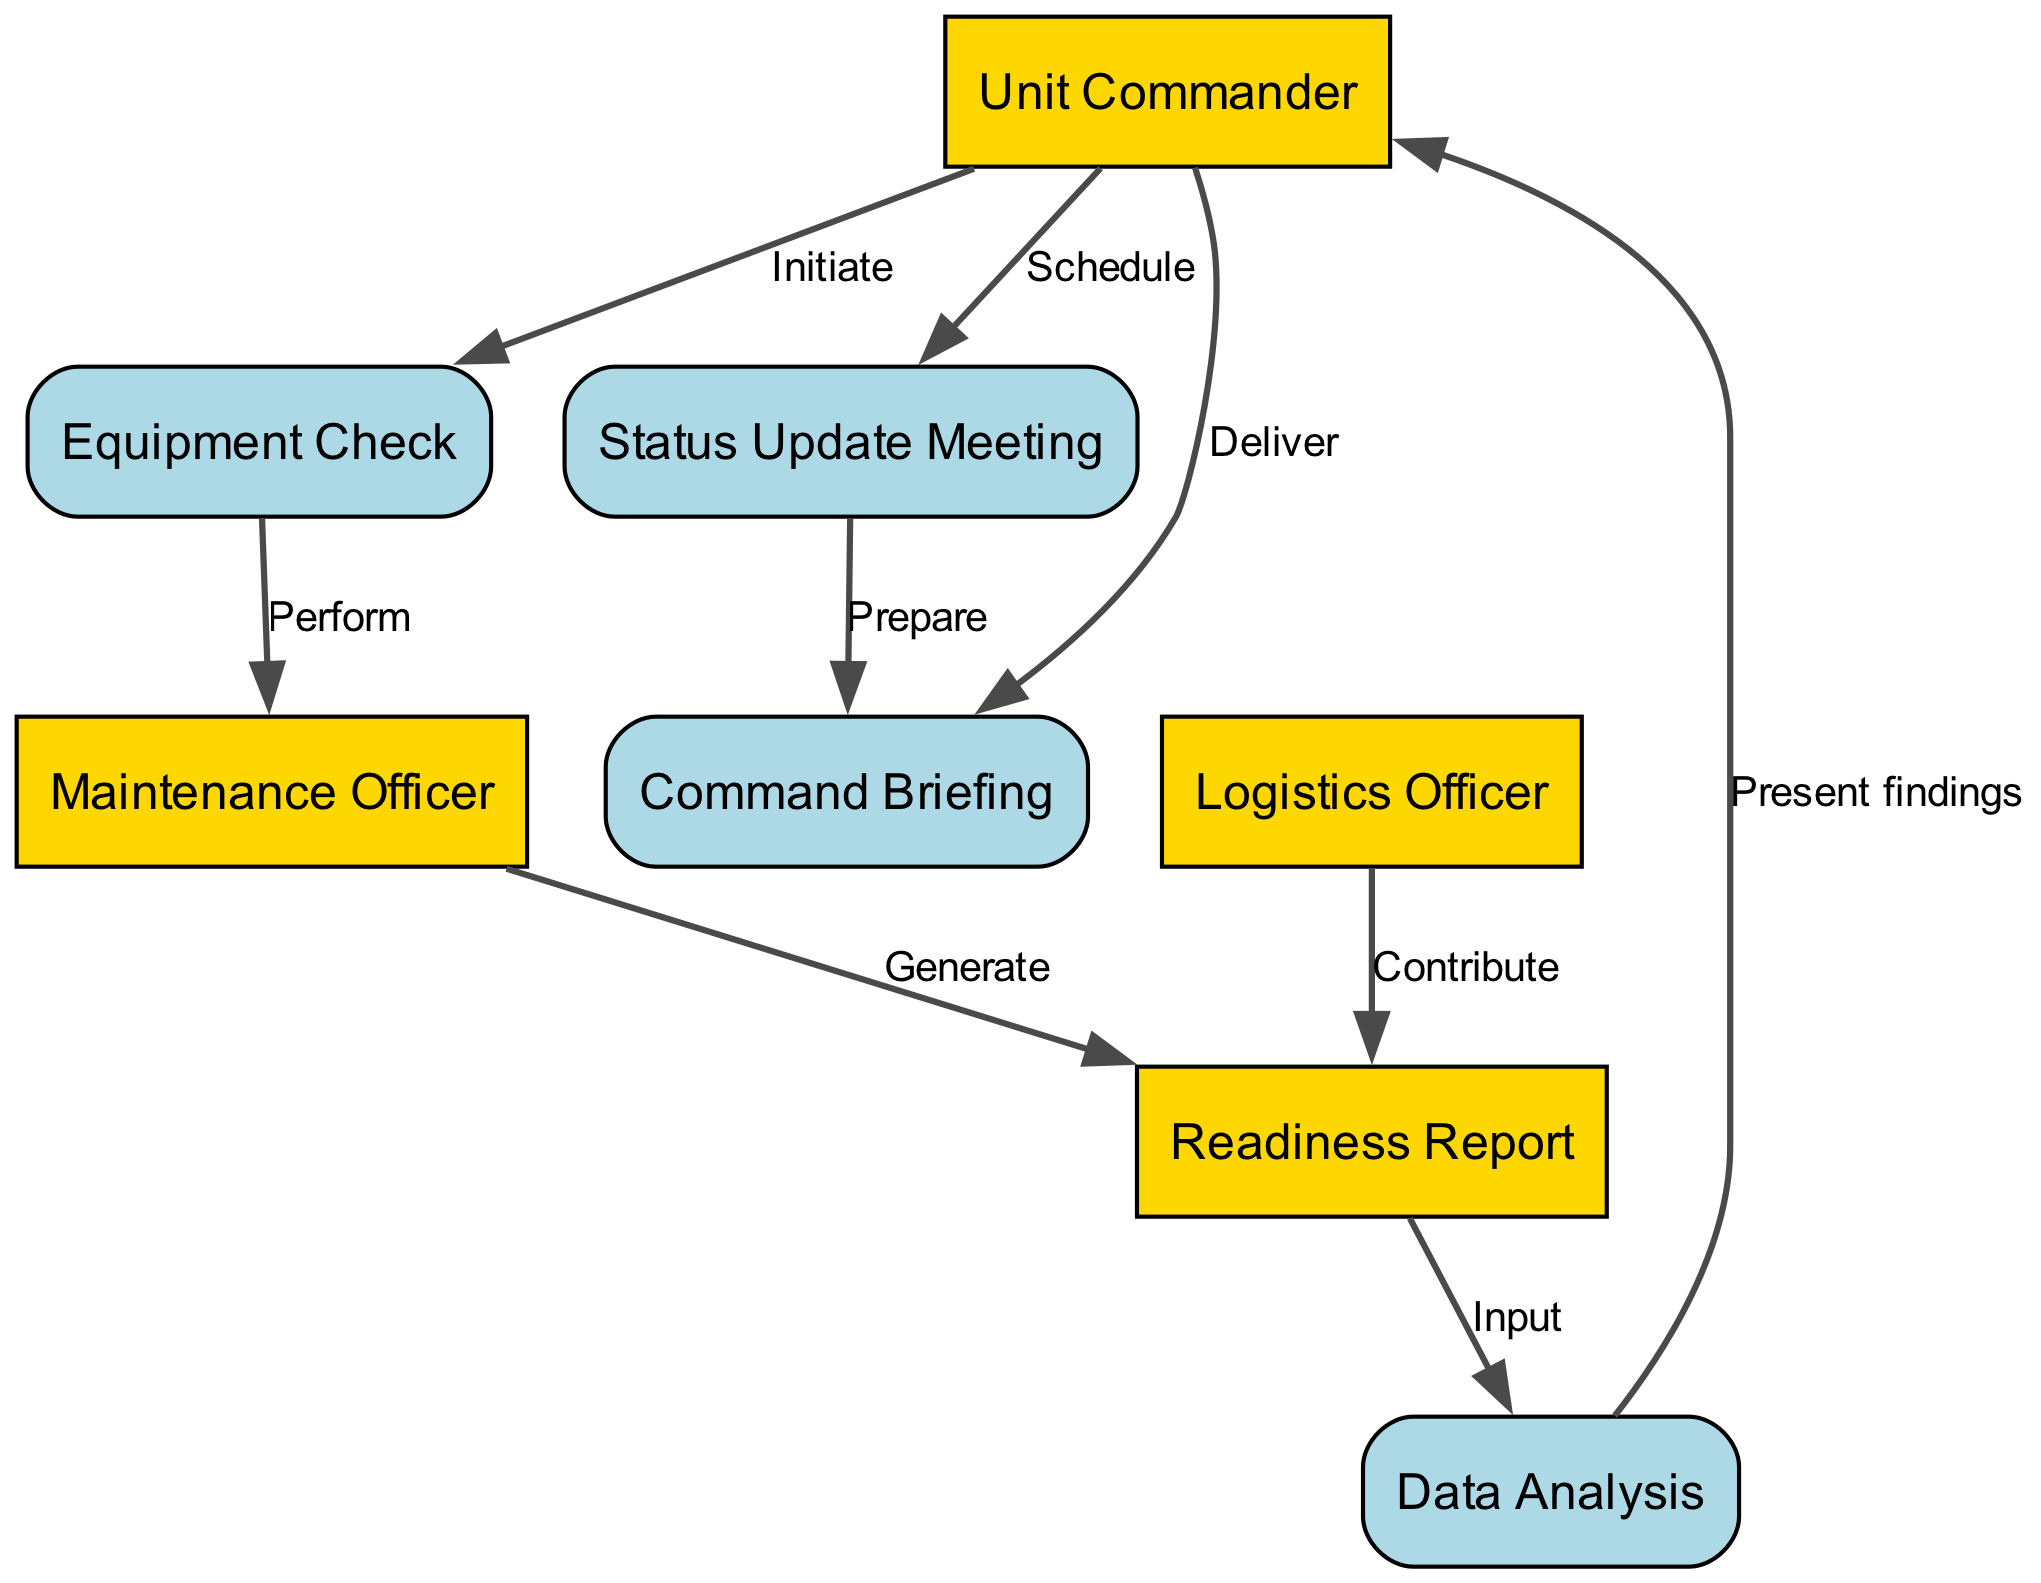What is the first process initiated in the diagram? The diagram shows that the first action is initiated by the Unit Commander who begins the Equipment Check. Therefore, the first process is Equipment Check.
Answer: Equipment Check How many actors are involved in the sequence diagram? There are four actors depicted in the diagram: Unit Commander, Maintenance Officer, Logistics Officer, and the object of the Readiness Report does not count as an actor. Thus, the total number of actors is four.
Answer: Four What does the Maintenance Officer generate as part of the sequence? According to the sequence, after performing the Equipment Check, the Maintenance Officer generates the Readiness Report as the next step.
Answer: Readiness Report Who is responsible for scheduling the Status Update Meeting? The diagram indicates that the Unit Commander is responsible for scheduling the Status Update Meeting after receiving the analyzed data.
Answer: Unit Commander What is the relationship between Data Analysis and Unit Commander? The Data Analysis process presents findings to the Unit Commander, establishing a direct informational flow between these two elements. This reflects a responsibility for the Unit Commander to consider these findings.
Answer: Present findings How many events are there in the sequence of this diagram? By reviewing the interactions illustrated in the diagram, there are a total of three distinct events: Status Update Meeting, Command Briefing, and the initial Equipment Check. Thus, the number of events is three.
Answer: Three What is the final action taken by the Unit Commander in the sequence? The last action taken by the Unit Commander is to deliver the Command Briefing, which concludes the processes involved in the sequence. Thus, the final action is to deliver the Command Briefing.
Answer: Deliver What does the Logistics Officer contribute to the Readiness Report? The Logistics Officer contributes information to the Readiness Report, which adds valuable context regarding the availability of spare parts for equipment maintenance.
Answer: Contribute 